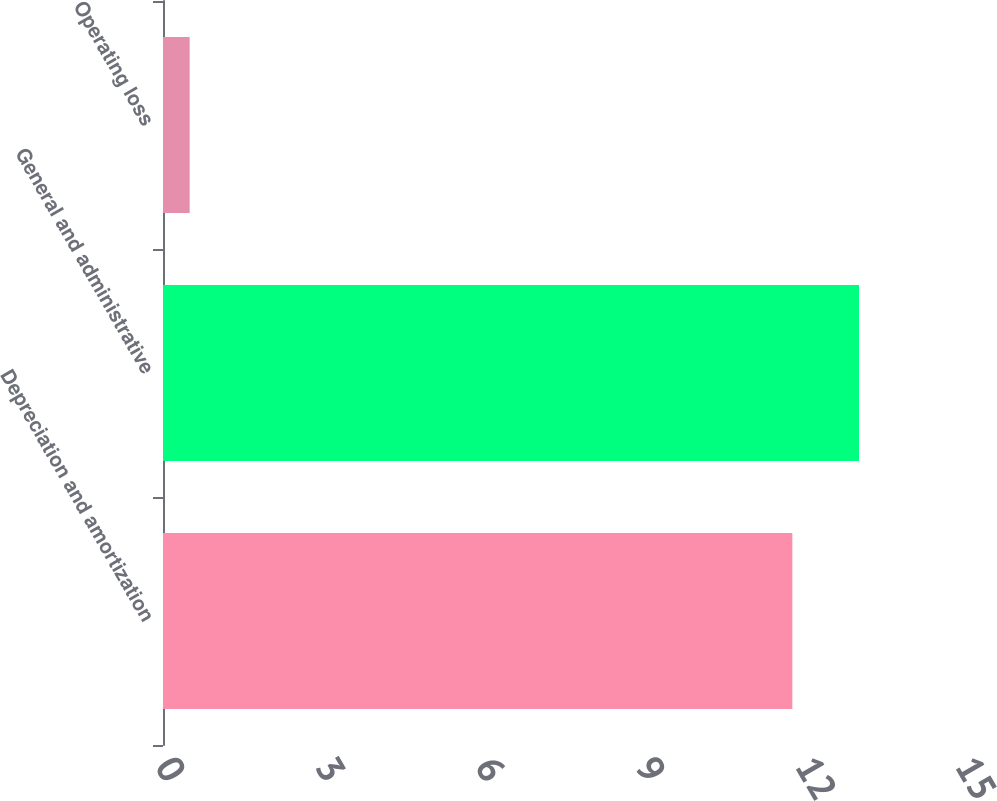Convert chart to OTSL. <chart><loc_0><loc_0><loc_500><loc_500><bar_chart><fcel>Depreciation and amortization<fcel>General and administrative<fcel>Operating loss<nl><fcel>11.8<fcel>13.05<fcel>0.5<nl></chart> 